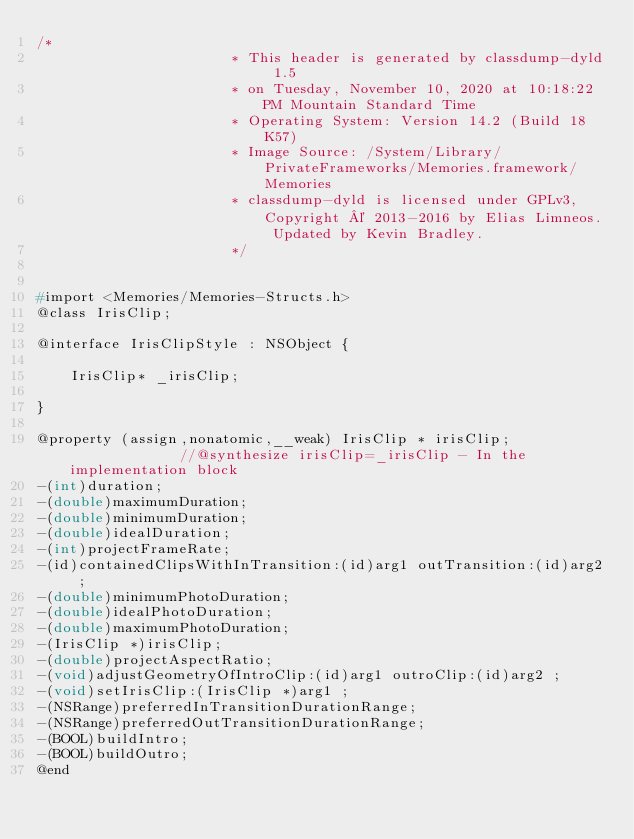Convert code to text. <code><loc_0><loc_0><loc_500><loc_500><_C_>/*
                       * This header is generated by classdump-dyld 1.5
                       * on Tuesday, November 10, 2020 at 10:18:22 PM Mountain Standard Time
                       * Operating System: Version 14.2 (Build 18K57)
                       * Image Source: /System/Library/PrivateFrameworks/Memories.framework/Memories
                       * classdump-dyld is licensed under GPLv3, Copyright © 2013-2016 by Elias Limneos. Updated by Kevin Bradley.
                       */


#import <Memories/Memories-Structs.h>
@class IrisClip;

@interface IrisClipStyle : NSObject {

	IrisClip* _irisClip;

}

@property (assign,nonatomic,__weak) IrisClip * irisClip;              //@synthesize irisClip=_irisClip - In the implementation block
-(int)duration;
-(double)maximumDuration;
-(double)minimumDuration;
-(double)idealDuration;
-(int)projectFrameRate;
-(id)containedClipsWithInTransition:(id)arg1 outTransition:(id)arg2 ;
-(double)minimumPhotoDuration;
-(double)idealPhotoDuration;
-(double)maximumPhotoDuration;
-(IrisClip *)irisClip;
-(double)projectAspectRatio;
-(void)adjustGeometryOfIntroClip:(id)arg1 outroClip:(id)arg2 ;
-(void)setIrisClip:(IrisClip *)arg1 ;
-(NSRange)preferredInTransitionDurationRange;
-(NSRange)preferredOutTransitionDurationRange;
-(BOOL)buildIntro;
-(BOOL)buildOutro;
@end

</code> 